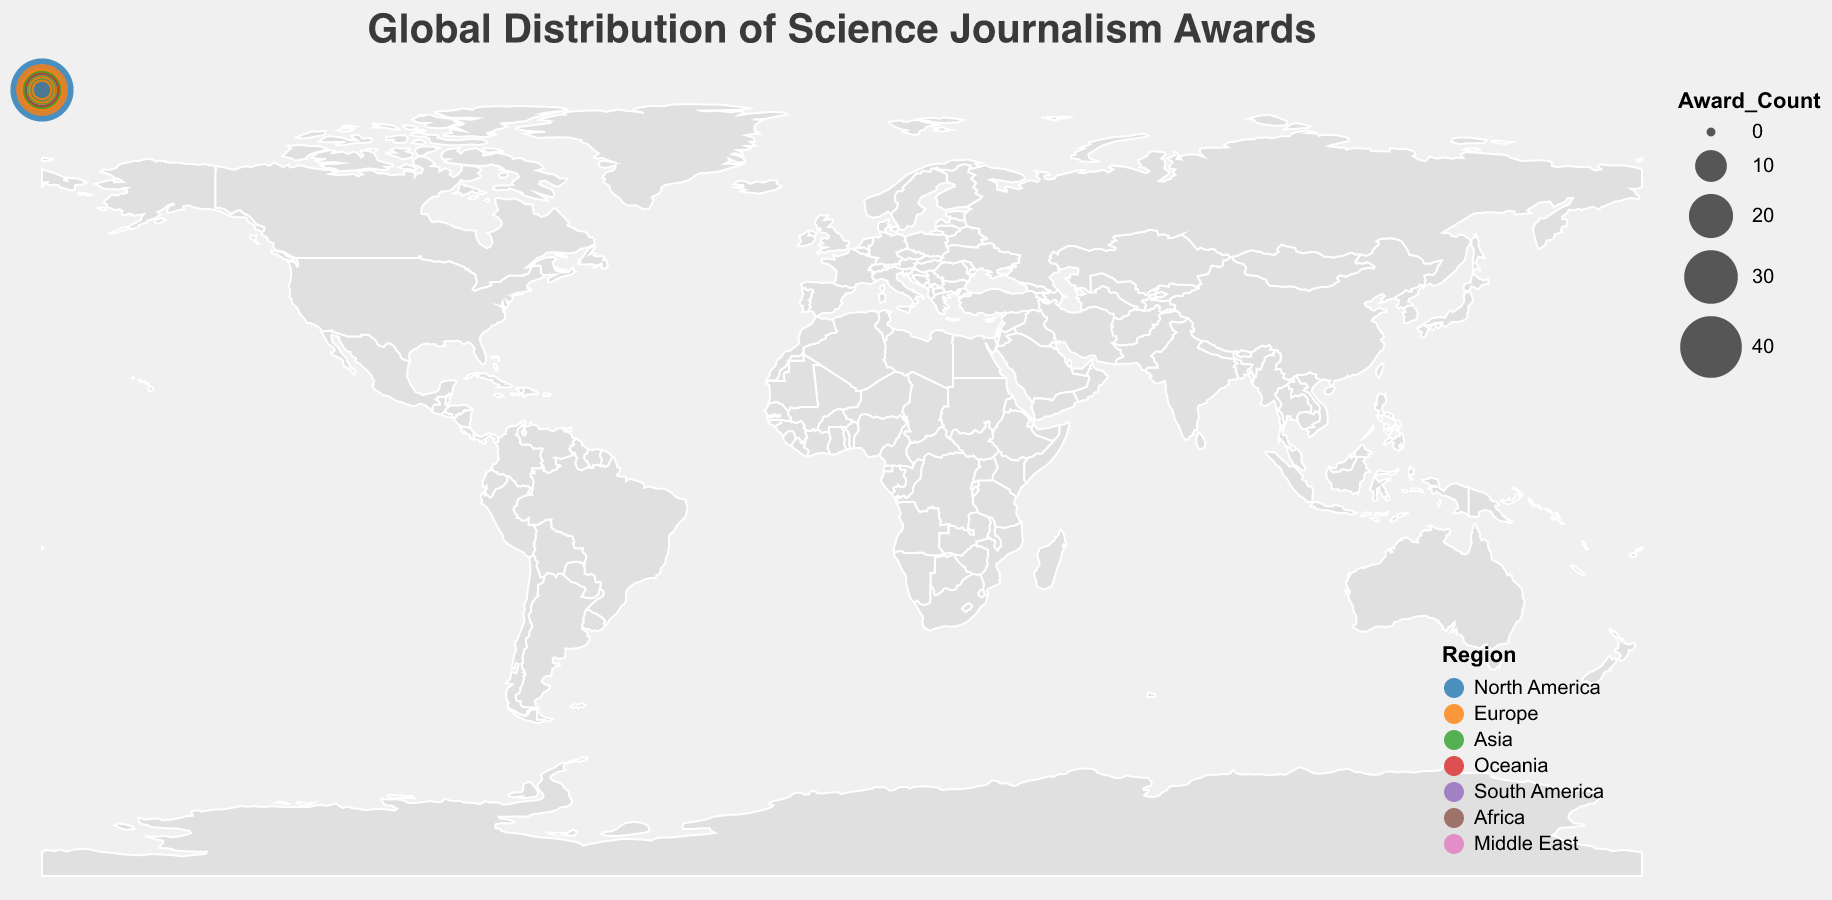What is the title of the figure? The title can be found at the top of the figure, prominently displayed. It helps identify what the geographic plot represents.
Answer: Global Distribution of Science Journalism Awards Which country has the highest number of awards? Identify the country with the largest circle on the plot. The tooltip or size of the circle indicates the number of awards.
Answer: United States In which region does Australia lie? By referring to the color coding and the tooltip information, we can determine the region for Australia.
Answer: Oceania How many awards are there in Europe in total? Sum the award counts of all countries in Europe: United Kingdom (28), Germany (18), France (9), Netherlands (7), Sweden (6), Spain (4), Russia (3), Switzerland (3), Italy (2). The total is 80.
Answer: 80 Which country has more awards, Canada or Japan? Compare the award counts from the tooltip information of Canada (10) and Japan (15). Thus, Japan has more awards.
Answer: Japan What is the average number of awards for the top 3 countries with the highest awards? Identify the top 3 countries (United States: 42, United Kingdom: 28, Germany: 18) and then calculate the average: (42 + 28 + 18) / 3 = 88 / 3 = 29.33
Answer: 29.33 How many countries have won more than 10 awards? Count the number of countries with award counts greater than 10 by referring to the tooltip information: United States, United Kingdom, Germany, Japan, Australia, Canada total to 6.
Answer: 6 Which region has the lowest number of awards and which country represents that count? By checking all regions and counting the awards, we find the Middle East has the least with only Israel listed having 3 awards.
Answer: Middle East, Israel What is the difference in award counts between the country with the most awards and the country with the second-most awards? Calculate the difference between the United States (42) and the United Kingdom (28). The difference is 42 - 28 = 14.
Answer: 14 